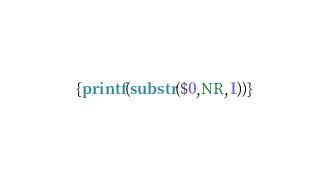Convert code to text. <code><loc_0><loc_0><loc_500><loc_500><_Awk_>{printf(substr($0,NR,1))}</code> 